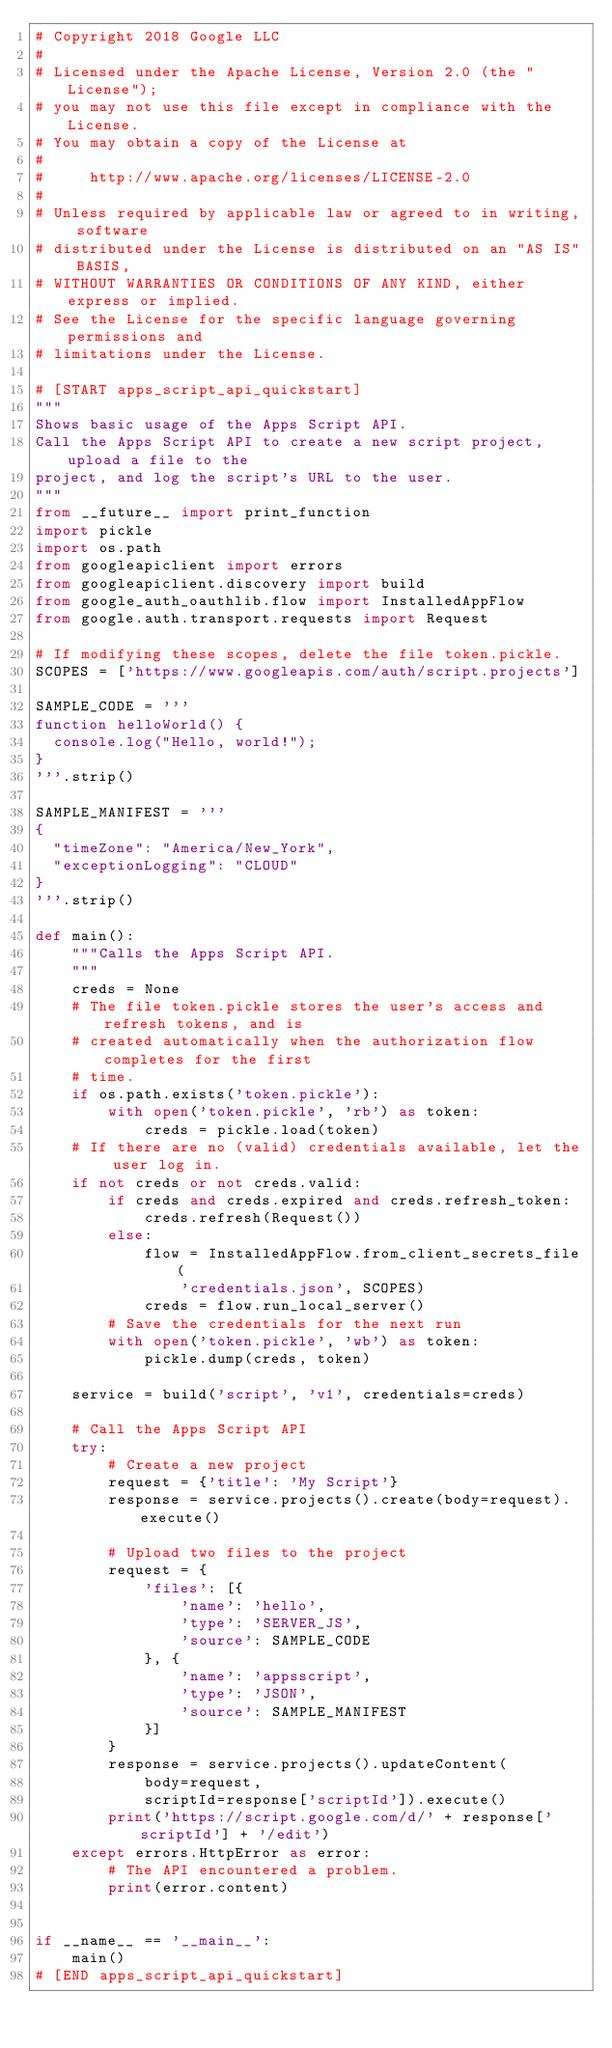<code> <loc_0><loc_0><loc_500><loc_500><_Python_># Copyright 2018 Google LLC
#
# Licensed under the Apache License, Version 2.0 (the "License");
# you may not use this file except in compliance with the License.
# You may obtain a copy of the License at
#
#     http://www.apache.org/licenses/LICENSE-2.0
#
# Unless required by applicable law or agreed to in writing, software
# distributed under the License is distributed on an "AS IS" BASIS,
# WITHOUT WARRANTIES OR CONDITIONS OF ANY KIND, either express or implied.
# See the License for the specific language governing permissions and
# limitations under the License.

# [START apps_script_api_quickstart]
"""
Shows basic usage of the Apps Script API.
Call the Apps Script API to create a new script project, upload a file to the
project, and log the script's URL to the user.
"""
from __future__ import print_function
import pickle
import os.path
from googleapiclient import errors
from googleapiclient.discovery import build
from google_auth_oauthlib.flow import InstalledAppFlow
from google.auth.transport.requests import Request

# If modifying these scopes, delete the file token.pickle.
SCOPES = ['https://www.googleapis.com/auth/script.projects']

SAMPLE_CODE = '''
function helloWorld() {
  console.log("Hello, world!");
}
'''.strip()

SAMPLE_MANIFEST = '''
{
  "timeZone": "America/New_York",
  "exceptionLogging": "CLOUD"
}
'''.strip()

def main():
    """Calls the Apps Script API.
    """
    creds = None
    # The file token.pickle stores the user's access and refresh tokens, and is
    # created automatically when the authorization flow completes for the first
    # time.
    if os.path.exists('token.pickle'):
        with open('token.pickle', 'rb') as token:
            creds = pickle.load(token)
    # If there are no (valid) credentials available, let the user log in.
    if not creds or not creds.valid:
        if creds and creds.expired and creds.refresh_token:
            creds.refresh(Request())
        else:
            flow = InstalledAppFlow.from_client_secrets_file(
                'credentials.json', SCOPES)
            creds = flow.run_local_server()
        # Save the credentials for the next run
        with open('token.pickle', 'wb') as token:
            pickle.dump(creds, token)

    service = build('script', 'v1', credentials=creds)

    # Call the Apps Script API
    try:
        # Create a new project
        request = {'title': 'My Script'}
        response = service.projects().create(body=request).execute()

        # Upload two files to the project
        request = {
            'files': [{
                'name': 'hello',
                'type': 'SERVER_JS',
                'source': SAMPLE_CODE
            }, {
                'name': 'appsscript',
                'type': 'JSON',
                'source': SAMPLE_MANIFEST
            }]
        }
        response = service.projects().updateContent(
            body=request,
            scriptId=response['scriptId']).execute()
        print('https://script.google.com/d/' + response['scriptId'] + '/edit')
    except errors.HttpError as error:
        # The API encountered a problem.
        print(error.content)


if __name__ == '__main__':
    main()
# [END apps_script_api_quickstart]
</code> 